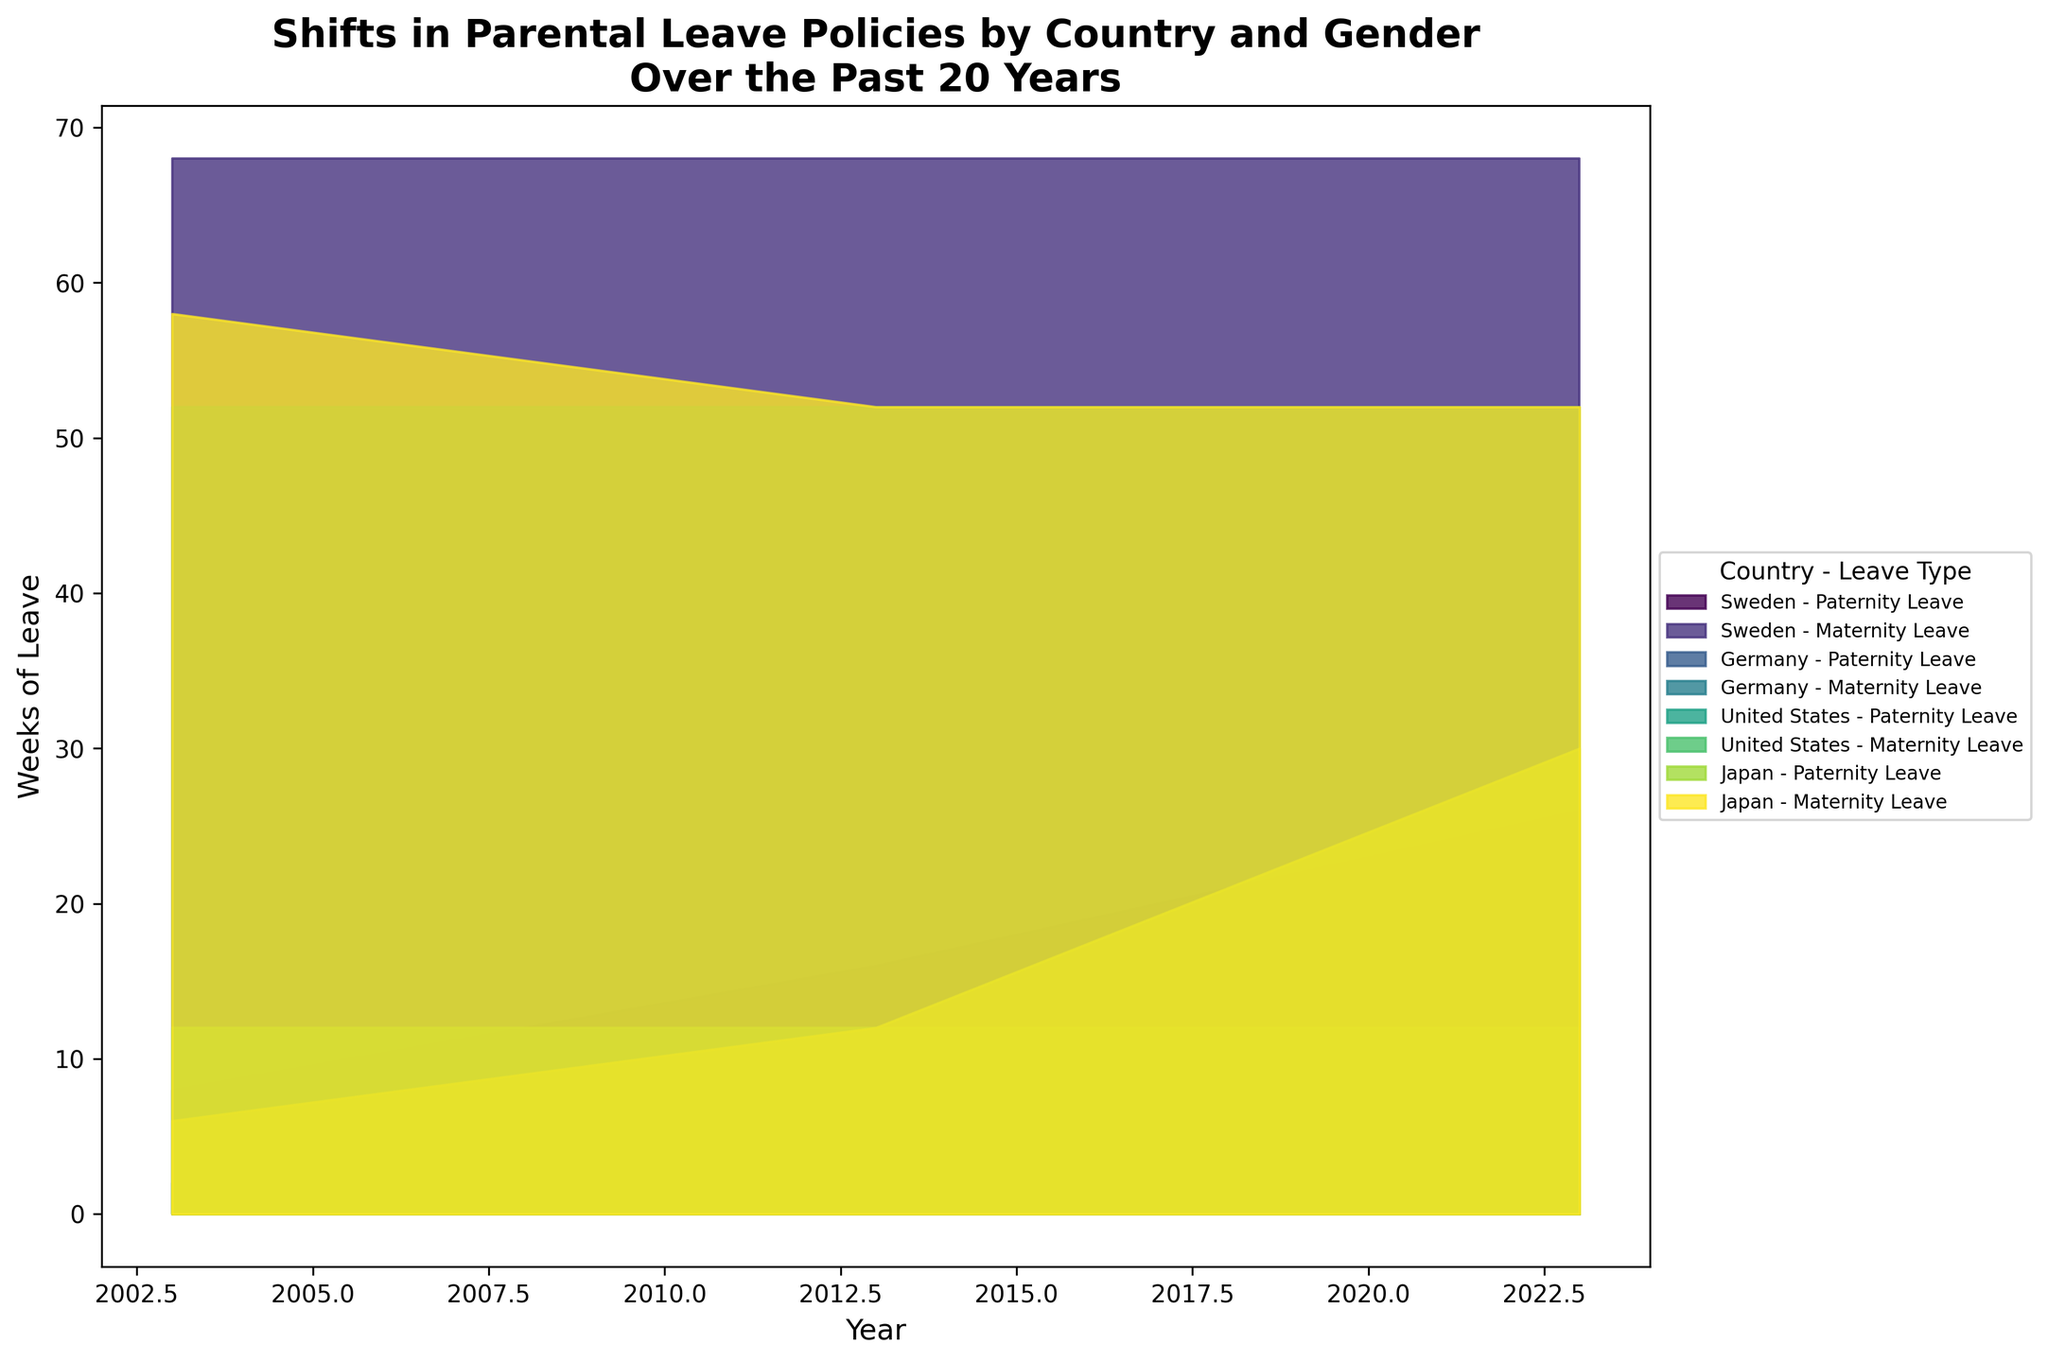What is the title of the figure? The title is usually displayed prominently at the top of the figure, describing what the figure is about. In this case, it’s "Shifts in Parental Leave Policies by Country and Gender Over the Past 20 Years"
Answer: Shifts in Parental Leave Policies by Country and Gender Over the Past 20 Years What does the x-axis represent? The x-axis generally represents the horizontal axis of the figure. Here, it shows the "Year," indicating the timeline over which the data changes.
Answer: Year What does the y-axis represent? The y-axis typically represents the vertical axis of a figure. In this case, it shows the "Weeks of Leave," indicating the amount of parental leave in weeks.
Answer: Weeks of Leave Which country had the highest paternity leave in 2023? To find this, examine the layers corresponding to paternity leave in 2023 and check which country has the highest point on the y-axis. Japan has the highest paternity leave of 30 weeks in 2023.
Answer: Japan How many countries are represented in the figure? By checking the different countries listed in the labels of the legend, we find that there are four countries represented: Sweden, Germany, United States, and Japan.
Answer: Four Compare the maternity leave in Germany and the United States in 2023. Which country offers more weeks? Look at the layers corresponding to maternity leave in Germany and the United States in the year 2023. Germany has 52 weeks, whereas the United States has 12 weeks. Germany offers more weeks.
Answer: Germany What is the difference in paternity leave in Japan between 2003 and 2023? Identify the number of weeks of paternity leave for Japan in 2003 and in 2023. In 2003, it is 6 weeks, and in 2023, it is 30 weeks. The difference is 30 - 6 = 24 weeks.
Answer: 24 weeks Which country showed no change in paternity leave over the 20 years? Observe each country's paternity leave layers across 2003, 2013, and 2023. The United States consistently shows 2 weeks of paternity leave across all these years.
Answer: United States What is the average maternity leave in Sweden over the 20 years? Check the maternity leave values for Sweden in 2003, 2013, and 2023. They are all 68 weeks. The average is (68 + 68 + 68) / 3 = 68 weeks.
Answer: 68 weeks How does the trend of paternity leave in Sweden compare to that in Japan over the 20 years? For Sweden, paternity leave increases from 8 weeks in 2003 to 16 weeks in 2013, and then to 26 weeks in 2023. For Japan, it increases from 6 weeks in 2003 to 12 weeks in 2013, and then to 30 weeks in 2023. Both countries show an increasing trend, but Japan’s increase is more significant.
Answer: Both increasing; Japan’s increase is more significant 